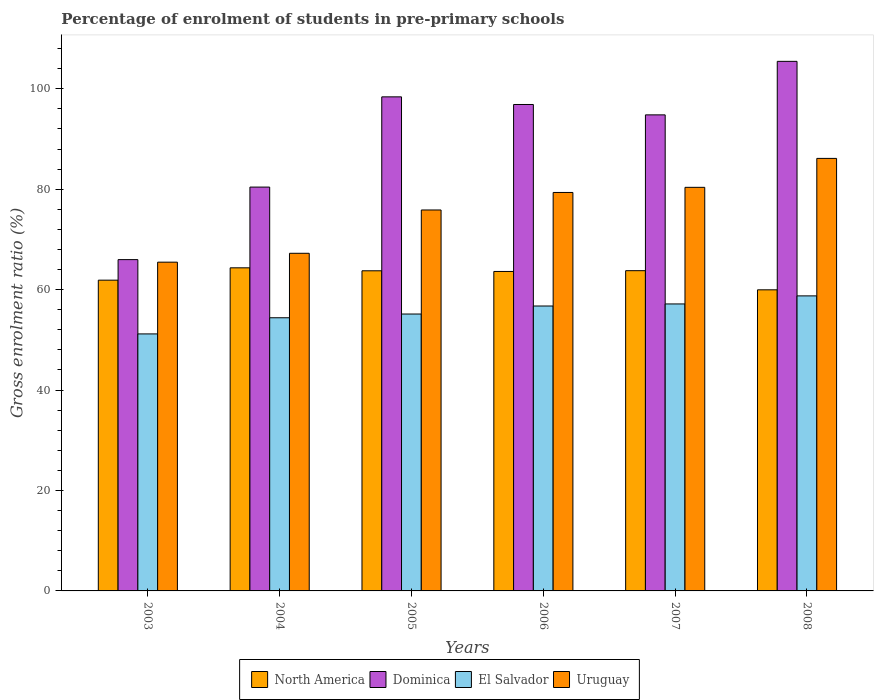How many groups of bars are there?
Offer a very short reply. 6. Are the number of bars on each tick of the X-axis equal?
Give a very brief answer. Yes. How many bars are there on the 1st tick from the left?
Your response must be concise. 4. What is the label of the 3rd group of bars from the left?
Provide a short and direct response. 2005. In how many cases, is the number of bars for a given year not equal to the number of legend labels?
Offer a very short reply. 0. What is the percentage of students enrolled in pre-primary schools in El Salvador in 2006?
Offer a terse response. 56.74. Across all years, what is the maximum percentage of students enrolled in pre-primary schools in El Salvador?
Your answer should be compact. 58.76. Across all years, what is the minimum percentage of students enrolled in pre-primary schools in Dominica?
Ensure brevity in your answer.  65.98. What is the total percentage of students enrolled in pre-primary schools in Uruguay in the graph?
Provide a succinct answer. 454.46. What is the difference between the percentage of students enrolled in pre-primary schools in Uruguay in 2005 and that in 2007?
Offer a terse response. -4.51. What is the difference between the percentage of students enrolled in pre-primary schools in El Salvador in 2008 and the percentage of students enrolled in pre-primary schools in North America in 2004?
Provide a short and direct response. -5.59. What is the average percentage of students enrolled in pre-primary schools in El Salvador per year?
Ensure brevity in your answer.  55.57. In the year 2003, what is the difference between the percentage of students enrolled in pre-primary schools in Dominica and percentage of students enrolled in pre-primary schools in North America?
Offer a very short reply. 4.09. What is the ratio of the percentage of students enrolled in pre-primary schools in North America in 2006 to that in 2007?
Keep it short and to the point. 1. Is the percentage of students enrolled in pre-primary schools in El Salvador in 2004 less than that in 2007?
Your answer should be very brief. Yes. Is the difference between the percentage of students enrolled in pre-primary schools in Dominica in 2005 and 2006 greater than the difference between the percentage of students enrolled in pre-primary schools in North America in 2005 and 2006?
Keep it short and to the point. Yes. What is the difference between the highest and the second highest percentage of students enrolled in pre-primary schools in Dominica?
Keep it short and to the point. 7.07. What is the difference between the highest and the lowest percentage of students enrolled in pre-primary schools in Dominica?
Your response must be concise. 39.49. Is the sum of the percentage of students enrolled in pre-primary schools in El Salvador in 2003 and 2006 greater than the maximum percentage of students enrolled in pre-primary schools in Uruguay across all years?
Ensure brevity in your answer.  Yes. Is it the case that in every year, the sum of the percentage of students enrolled in pre-primary schools in Dominica and percentage of students enrolled in pre-primary schools in El Salvador is greater than the sum of percentage of students enrolled in pre-primary schools in Uruguay and percentage of students enrolled in pre-primary schools in North America?
Your answer should be compact. No. What does the 2nd bar from the left in 2008 represents?
Give a very brief answer. Dominica. How many bars are there?
Offer a terse response. 24. How many years are there in the graph?
Your answer should be compact. 6. Are the values on the major ticks of Y-axis written in scientific E-notation?
Ensure brevity in your answer.  No. Does the graph contain any zero values?
Give a very brief answer. No. How are the legend labels stacked?
Ensure brevity in your answer.  Horizontal. What is the title of the graph?
Provide a short and direct response. Percentage of enrolment of students in pre-primary schools. What is the label or title of the X-axis?
Your answer should be compact. Years. What is the Gross enrolment ratio (%) of North America in 2003?
Offer a terse response. 61.89. What is the Gross enrolment ratio (%) in Dominica in 2003?
Give a very brief answer. 65.98. What is the Gross enrolment ratio (%) of El Salvador in 2003?
Offer a very short reply. 51.18. What is the Gross enrolment ratio (%) of Uruguay in 2003?
Keep it short and to the point. 65.48. What is the Gross enrolment ratio (%) of North America in 2004?
Keep it short and to the point. 64.35. What is the Gross enrolment ratio (%) of Dominica in 2004?
Your answer should be compact. 80.43. What is the Gross enrolment ratio (%) of El Salvador in 2004?
Your response must be concise. 54.4. What is the Gross enrolment ratio (%) of Uruguay in 2004?
Make the answer very short. 67.24. What is the Gross enrolment ratio (%) in North America in 2005?
Offer a very short reply. 63.76. What is the Gross enrolment ratio (%) of Dominica in 2005?
Your answer should be compact. 98.4. What is the Gross enrolment ratio (%) in El Salvador in 2005?
Give a very brief answer. 55.15. What is the Gross enrolment ratio (%) of Uruguay in 2005?
Give a very brief answer. 75.87. What is the Gross enrolment ratio (%) of North America in 2006?
Your answer should be compact. 63.62. What is the Gross enrolment ratio (%) of Dominica in 2006?
Your answer should be very brief. 96.88. What is the Gross enrolment ratio (%) in El Salvador in 2006?
Give a very brief answer. 56.74. What is the Gross enrolment ratio (%) in Uruguay in 2006?
Your answer should be very brief. 79.36. What is the Gross enrolment ratio (%) in North America in 2007?
Provide a short and direct response. 63.78. What is the Gross enrolment ratio (%) of Dominica in 2007?
Give a very brief answer. 94.81. What is the Gross enrolment ratio (%) of El Salvador in 2007?
Your answer should be very brief. 57.15. What is the Gross enrolment ratio (%) in Uruguay in 2007?
Keep it short and to the point. 80.38. What is the Gross enrolment ratio (%) in North America in 2008?
Make the answer very short. 59.97. What is the Gross enrolment ratio (%) of Dominica in 2008?
Provide a succinct answer. 105.47. What is the Gross enrolment ratio (%) of El Salvador in 2008?
Your answer should be compact. 58.76. What is the Gross enrolment ratio (%) in Uruguay in 2008?
Make the answer very short. 86.14. Across all years, what is the maximum Gross enrolment ratio (%) in North America?
Offer a terse response. 64.35. Across all years, what is the maximum Gross enrolment ratio (%) in Dominica?
Keep it short and to the point. 105.47. Across all years, what is the maximum Gross enrolment ratio (%) of El Salvador?
Keep it short and to the point. 58.76. Across all years, what is the maximum Gross enrolment ratio (%) in Uruguay?
Provide a succinct answer. 86.14. Across all years, what is the minimum Gross enrolment ratio (%) of North America?
Provide a succinct answer. 59.97. Across all years, what is the minimum Gross enrolment ratio (%) in Dominica?
Provide a succinct answer. 65.98. Across all years, what is the minimum Gross enrolment ratio (%) of El Salvador?
Make the answer very short. 51.18. Across all years, what is the minimum Gross enrolment ratio (%) of Uruguay?
Provide a short and direct response. 65.48. What is the total Gross enrolment ratio (%) in North America in the graph?
Your answer should be very brief. 377.37. What is the total Gross enrolment ratio (%) of Dominica in the graph?
Your response must be concise. 541.96. What is the total Gross enrolment ratio (%) of El Salvador in the graph?
Keep it short and to the point. 333.39. What is the total Gross enrolment ratio (%) of Uruguay in the graph?
Offer a terse response. 454.46. What is the difference between the Gross enrolment ratio (%) of North America in 2003 and that in 2004?
Your response must be concise. -2.46. What is the difference between the Gross enrolment ratio (%) of Dominica in 2003 and that in 2004?
Your answer should be compact. -14.44. What is the difference between the Gross enrolment ratio (%) of El Salvador in 2003 and that in 2004?
Give a very brief answer. -3.22. What is the difference between the Gross enrolment ratio (%) in Uruguay in 2003 and that in 2004?
Your response must be concise. -1.77. What is the difference between the Gross enrolment ratio (%) in North America in 2003 and that in 2005?
Offer a terse response. -1.87. What is the difference between the Gross enrolment ratio (%) of Dominica in 2003 and that in 2005?
Provide a short and direct response. -32.41. What is the difference between the Gross enrolment ratio (%) of El Salvador in 2003 and that in 2005?
Your answer should be compact. -3.96. What is the difference between the Gross enrolment ratio (%) in Uruguay in 2003 and that in 2005?
Ensure brevity in your answer.  -10.39. What is the difference between the Gross enrolment ratio (%) of North America in 2003 and that in 2006?
Ensure brevity in your answer.  -1.73. What is the difference between the Gross enrolment ratio (%) of Dominica in 2003 and that in 2006?
Provide a short and direct response. -30.89. What is the difference between the Gross enrolment ratio (%) in El Salvador in 2003 and that in 2006?
Offer a terse response. -5.56. What is the difference between the Gross enrolment ratio (%) in Uruguay in 2003 and that in 2006?
Give a very brief answer. -13.88. What is the difference between the Gross enrolment ratio (%) of North America in 2003 and that in 2007?
Give a very brief answer. -1.89. What is the difference between the Gross enrolment ratio (%) of Dominica in 2003 and that in 2007?
Your response must be concise. -28.83. What is the difference between the Gross enrolment ratio (%) of El Salvador in 2003 and that in 2007?
Your response must be concise. -5.97. What is the difference between the Gross enrolment ratio (%) in Uruguay in 2003 and that in 2007?
Offer a very short reply. -14.9. What is the difference between the Gross enrolment ratio (%) of North America in 2003 and that in 2008?
Provide a short and direct response. 1.92. What is the difference between the Gross enrolment ratio (%) of Dominica in 2003 and that in 2008?
Provide a succinct answer. -39.49. What is the difference between the Gross enrolment ratio (%) of El Salvador in 2003 and that in 2008?
Your answer should be compact. -7.58. What is the difference between the Gross enrolment ratio (%) in Uruguay in 2003 and that in 2008?
Offer a terse response. -20.66. What is the difference between the Gross enrolment ratio (%) in North America in 2004 and that in 2005?
Provide a succinct answer. 0.59. What is the difference between the Gross enrolment ratio (%) of Dominica in 2004 and that in 2005?
Keep it short and to the point. -17.97. What is the difference between the Gross enrolment ratio (%) in El Salvador in 2004 and that in 2005?
Your answer should be compact. -0.74. What is the difference between the Gross enrolment ratio (%) of Uruguay in 2004 and that in 2005?
Provide a short and direct response. -8.63. What is the difference between the Gross enrolment ratio (%) in North America in 2004 and that in 2006?
Give a very brief answer. 0.73. What is the difference between the Gross enrolment ratio (%) in Dominica in 2004 and that in 2006?
Keep it short and to the point. -16.45. What is the difference between the Gross enrolment ratio (%) of El Salvador in 2004 and that in 2006?
Provide a short and direct response. -2.34. What is the difference between the Gross enrolment ratio (%) in Uruguay in 2004 and that in 2006?
Make the answer very short. -12.11. What is the difference between the Gross enrolment ratio (%) of North America in 2004 and that in 2007?
Your response must be concise. 0.57. What is the difference between the Gross enrolment ratio (%) of Dominica in 2004 and that in 2007?
Your response must be concise. -14.38. What is the difference between the Gross enrolment ratio (%) of El Salvador in 2004 and that in 2007?
Keep it short and to the point. -2.75. What is the difference between the Gross enrolment ratio (%) of Uruguay in 2004 and that in 2007?
Your response must be concise. -13.14. What is the difference between the Gross enrolment ratio (%) of North America in 2004 and that in 2008?
Offer a very short reply. 4.38. What is the difference between the Gross enrolment ratio (%) in Dominica in 2004 and that in 2008?
Give a very brief answer. -25.04. What is the difference between the Gross enrolment ratio (%) in El Salvador in 2004 and that in 2008?
Offer a very short reply. -4.36. What is the difference between the Gross enrolment ratio (%) of Uruguay in 2004 and that in 2008?
Provide a short and direct response. -18.9. What is the difference between the Gross enrolment ratio (%) in North America in 2005 and that in 2006?
Offer a very short reply. 0.14. What is the difference between the Gross enrolment ratio (%) in Dominica in 2005 and that in 2006?
Ensure brevity in your answer.  1.52. What is the difference between the Gross enrolment ratio (%) in El Salvador in 2005 and that in 2006?
Your answer should be very brief. -1.6. What is the difference between the Gross enrolment ratio (%) in Uruguay in 2005 and that in 2006?
Offer a very short reply. -3.49. What is the difference between the Gross enrolment ratio (%) of North America in 2005 and that in 2007?
Ensure brevity in your answer.  -0.02. What is the difference between the Gross enrolment ratio (%) of Dominica in 2005 and that in 2007?
Give a very brief answer. 3.59. What is the difference between the Gross enrolment ratio (%) of El Salvador in 2005 and that in 2007?
Your response must be concise. -2.01. What is the difference between the Gross enrolment ratio (%) of Uruguay in 2005 and that in 2007?
Provide a succinct answer. -4.51. What is the difference between the Gross enrolment ratio (%) in North America in 2005 and that in 2008?
Your answer should be compact. 3.79. What is the difference between the Gross enrolment ratio (%) of Dominica in 2005 and that in 2008?
Make the answer very short. -7.07. What is the difference between the Gross enrolment ratio (%) in El Salvador in 2005 and that in 2008?
Give a very brief answer. -3.61. What is the difference between the Gross enrolment ratio (%) of Uruguay in 2005 and that in 2008?
Your response must be concise. -10.27. What is the difference between the Gross enrolment ratio (%) in North America in 2006 and that in 2007?
Make the answer very short. -0.16. What is the difference between the Gross enrolment ratio (%) of Dominica in 2006 and that in 2007?
Offer a very short reply. 2.07. What is the difference between the Gross enrolment ratio (%) in El Salvador in 2006 and that in 2007?
Keep it short and to the point. -0.41. What is the difference between the Gross enrolment ratio (%) in Uruguay in 2006 and that in 2007?
Your answer should be very brief. -1.02. What is the difference between the Gross enrolment ratio (%) in North America in 2006 and that in 2008?
Keep it short and to the point. 3.65. What is the difference between the Gross enrolment ratio (%) in Dominica in 2006 and that in 2008?
Offer a terse response. -8.59. What is the difference between the Gross enrolment ratio (%) of El Salvador in 2006 and that in 2008?
Your answer should be very brief. -2.02. What is the difference between the Gross enrolment ratio (%) of Uruguay in 2006 and that in 2008?
Your answer should be compact. -6.78. What is the difference between the Gross enrolment ratio (%) of North America in 2007 and that in 2008?
Ensure brevity in your answer.  3.81. What is the difference between the Gross enrolment ratio (%) in Dominica in 2007 and that in 2008?
Keep it short and to the point. -10.66. What is the difference between the Gross enrolment ratio (%) in El Salvador in 2007 and that in 2008?
Offer a very short reply. -1.61. What is the difference between the Gross enrolment ratio (%) of Uruguay in 2007 and that in 2008?
Offer a terse response. -5.76. What is the difference between the Gross enrolment ratio (%) in North America in 2003 and the Gross enrolment ratio (%) in Dominica in 2004?
Your response must be concise. -18.54. What is the difference between the Gross enrolment ratio (%) in North America in 2003 and the Gross enrolment ratio (%) in El Salvador in 2004?
Make the answer very short. 7.48. What is the difference between the Gross enrolment ratio (%) in North America in 2003 and the Gross enrolment ratio (%) in Uruguay in 2004?
Your answer should be compact. -5.35. What is the difference between the Gross enrolment ratio (%) of Dominica in 2003 and the Gross enrolment ratio (%) of El Salvador in 2004?
Give a very brief answer. 11.58. What is the difference between the Gross enrolment ratio (%) of Dominica in 2003 and the Gross enrolment ratio (%) of Uruguay in 2004?
Offer a very short reply. -1.26. What is the difference between the Gross enrolment ratio (%) of El Salvador in 2003 and the Gross enrolment ratio (%) of Uruguay in 2004?
Make the answer very short. -16.06. What is the difference between the Gross enrolment ratio (%) of North America in 2003 and the Gross enrolment ratio (%) of Dominica in 2005?
Offer a terse response. -36.51. What is the difference between the Gross enrolment ratio (%) of North America in 2003 and the Gross enrolment ratio (%) of El Salvador in 2005?
Keep it short and to the point. 6.74. What is the difference between the Gross enrolment ratio (%) of North America in 2003 and the Gross enrolment ratio (%) of Uruguay in 2005?
Offer a very short reply. -13.98. What is the difference between the Gross enrolment ratio (%) of Dominica in 2003 and the Gross enrolment ratio (%) of El Salvador in 2005?
Provide a succinct answer. 10.84. What is the difference between the Gross enrolment ratio (%) in Dominica in 2003 and the Gross enrolment ratio (%) in Uruguay in 2005?
Give a very brief answer. -9.89. What is the difference between the Gross enrolment ratio (%) of El Salvador in 2003 and the Gross enrolment ratio (%) of Uruguay in 2005?
Keep it short and to the point. -24.68. What is the difference between the Gross enrolment ratio (%) of North America in 2003 and the Gross enrolment ratio (%) of Dominica in 2006?
Make the answer very short. -34.99. What is the difference between the Gross enrolment ratio (%) of North America in 2003 and the Gross enrolment ratio (%) of El Salvador in 2006?
Give a very brief answer. 5.15. What is the difference between the Gross enrolment ratio (%) of North America in 2003 and the Gross enrolment ratio (%) of Uruguay in 2006?
Ensure brevity in your answer.  -17.47. What is the difference between the Gross enrolment ratio (%) in Dominica in 2003 and the Gross enrolment ratio (%) in El Salvador in 2006?
Offer a terse response. 9.24. What is the difference between the Gross enrolment ratio (%) in Dominica in 2003 and the Gross enrolment ratio (%) in Uruguay in 2006?
Provide a short and direct response. -13.37. What is the difference between the Gross enrolment ratio (%) of El Salvador in 2003 and the Gross enrolment ratio (%) of Uruguay in 2006?
Provide a short and direct response. -28.17. What is the difference between the Gross enrolment ratio (%) of North America in 2003 and the Gross enrolment ratio (%) of Dominica in 2007?
Your answer should be compact. -32.92. What is the difference between the Gross enrolment ratio (%) in North America in 2003 and the Gross enrolment ratio (%) in El Salvador in 2007?
Give a very brief answer. 4.74. What is the difference between the Gross enrolment ratio (%) in North America in 2003 and the Gross enrolment ratio (%) in Uruguay in 2007?
Offer a very short reply. -18.49. What is the difference between the Gross enrolment ratio (%) in Dominica in 2003 and the Gross enrolment ratio (%) in El Salvador in 2007?
Your response must be concise. 8.83. What is the difference between the Gross enrolment ratio (%) in Dominica in 2003 and the Gross enrolment ratio (%) in Uruguay in 2007?
Keep it short and to the point. -14.39. What is the difference between the Gross enrolment ratio (%) of El Salvador in 2003 and the Gross enrolment ratio (%) of Uruguay in 2007?
Make the answer very short. -29.19. What is the difference between the Gross enrolment ratio (%) in North America in 2003 and the Gross enrolment ratio (%) in Dominica in 2008?
Ensure brevity in your answer.  -43.58. What is the difference between the Gross enrolment ratio (%) of North America in 2003 and the Gross enrolment ratio (%) of El Salvador in 2008?
Ensure brevity in your answer.  3.13. What is the difference between the Gross enrolment ratio (%) of North America in 2003 and the Gross enrolment ratio (%) of Uruguay in 2008?
Your response must be concise. -24.25. What is the difference between the Gross enrolment ratio (%) in Dominica in 2003 and the Gross enrolment ratio (%) in El Salvador in 2008?
Offer a terse response. 7.22. What is the difference between the Gross enrolment ratio (%) in Dominica in 2003 and the Gross enrolment ratio (%) in Uruguay in 2008?
Keep it short and to the point. -20.16. What is the difference between the Gross enrolment ratio (%) of El Salvador in 2003 and the Gross enrolment ratio (%) of Uruguay in 2008?
Provide a succinct answer. -34.96. What is the difference between the Gross enrolment ratio (%) of North America in 2004 and the Gross enrolment ratio (%) of Dominica in 2005?
Offer a very short reply. -34.05. What is the difference between the Gross enrolment ratio (%) in North America in 2004 and the Gross enrolment ratio (%) in El Salvador in 2005?
Offer a very short reply. 9.2. What is the difference between the Gross enrolment ratio (%) in North America in 2004 and the Gross enrolment ratio (%) in Uruguay in 2005?
Offer a very short reply. -11.52. What is the difference between the Gross enrolment ratio (%) in Dominica in 2004 and the Gross enrolment ratio (%) in El Salvador in 2005?
Your response must be concise. 25.28. What is the difference between the Gross enrolment ratio (%) in Dominica in 2004 and the Gross enrolment ratio (%) in Uruguay in 2005?
Offer a very short reply. 4.56. What is the difference between the Gross enrolment ratio (%) in El Salvador in 2004 and the Gross enrolment ratio (%) in Uruguay in 2005?
Keep it short and to the point. -21.46. What is the difference between the Gross enrolment ratio (%) of North America in 2004 and the Gross enrolment ratio (%) of Dominica in 2006?
Offer a terse response. -32.53. What is the difference between the Gross enrolment ratio (%) of North America in 2004 and the Gross enrolment ratio (%) of El Salvador in 2006?
Provide a succinct answer. 7.61. What is the difference between the Gross enrolment ratio (%) in North America in 2004 and the Gross enrolment ratio (%) in Uruguay in 2006?
Make the answer very short. -15.01. What is the difference between the Gross enrolment ratio (%) in Dominica in 2004 and the Gross enrolment ratio (%) in El Salvador in 2006?
Make the answer very short. 23.68. What is the difference between the Gross enrolment ratio (%) of Dominica in 2004 and the Gross enrolment ratio (%) of Uruguay in 2006?
Ensure brevity in your answer.  1.07. What is the difference between the Gross enrolment ratio (%) in El Salvador in 2004 and the Gross enrolment ratio (%) in Uruguay in 2006?
Offer a very short reply. -24.95. What is the difference between the Gross enrolment ratio (%) of North America in 2004 and the Gross enrolment ratio (%) of Dominica in 2007?
Provide a succinct answer. -30.46. What is the difference between the Gross enrolment ratio (%) in North America in 2004 and the Gross enrolment ratio (%) in El Salvador in 2007?
Give a very brief answer. 7.2. What is the difference between the Gross enrolment ratio (%) of North America in 2004 and the Gross enrolment ratio (%) of Uruguay in 2007?
Make the answer very short. -16.03. What is the difference between the Gross enrolment ratio (%) in Dominica in 2004 and the Gross enrolment ratio (%) in El Salvador in 2007?
Give a very brief answer. 23.27. What is the difference between the Gross enrolment ratio (%) in Dominica in 2004 and the Gross enrolment ratio (%) in Uruguay in 2007?
Give a very brief answer. 0.05. What is the difference between the Gross enrolment ratio (%) in El Salvador in 2004 and the Gross enrolment ratio (%) in Uruguay in 2007?
Your response must be concise. -25.97. What is the difference between the Gross enrolment ratio (%) in North America in 2004 and the Gross enrolment ratio (%) in Dominica in 2008?
Provide a short and direct response. -41.12. What is the difference between the Gross enrolment ratio (%) of North America in 2004 and the Gross enrolment ratio (%) of El Salvador in 2008?
Provide a short and direct response. 5.59. What is the difference between the Gross enrolment ratio (%) of North America in 2004 and the Gross enrolment ratio (%) of Uruguay in 2008?
Your response must be concise. -21.79. What is the difference between the Gross enrolment ratio (%) of Dominica in 2004 and the Gross enrolment ratio (%) of El Salvador in 2008?
Your answer should be compact. 21.67. What is the difference between the Gross enrolment ratio (%) in Dominica in 2004 and the Gross enrolment ratio (%) in Uruguay in 2008?
Your response must be concise. -5.71. What is the difference between the Gross enrolment ratio (%) of El Salvador in 2004 and the Gross enrolment ratio (%) of Uruguay in 2008?
Ensure brevity in your answer.  -31.74. What is the difference between the Gross enrolment ratio (%) in North America in 2005 and the Gross enrolment ratio (%) in Dominica in 2006?
Provide a short and direct response. -33.12. What is the difference between the Gross enrolment ratio (%) of North America in 2005 and the Gross enrolment ratio (%) of El Salvador in 2006?
Offer a terse response. 7.01. What is the difference between the Gross enrolment ratio (%) of North America in 2005 and the Gross enrolment ratio (%) of Uruguay in 2006?
Provide a succinct answer. -15.6. What is the difference between the Gross enrolment ratio (%) in Dominica in 2005 and the Gross enrolment ratio (%) in El Salvador in 2006?
Your answer should be compact. 41.65. What is the difference between the Gross enrolment ratio (%) of Dominica in 2005 and the Gross enrolment ratio (%) of Uruguay in 2006?
Offer a terse response. 19.04. What is the difference between the Gross enrolment ratio (%) of El Salvador in 2005 and the Gross enrolment ratio (%) of Uruguay in 2006?
Give a very brief answer. -24.21. What is the difference between the Gross enrolment ratio (%) in North America in 2005 and the Gross enrolment ratio (%) in Dominica in 2007?
Ensure brevity in your answer.  -31.05. What is the difference between the Gross enrolment ratio (%) of North America in 2005 and the Gross enrolment ratio (%) of El Salvador in 2007?
Keep it short and to the point. 6.6. What is the difference between the Gross enrolment ratio (%) in North America in 2005 and the Gross enrolment ratio (%) in Uruguay in 2007?
Make the answer very short. -16.62. What is the difference between the Gross enrolment ratio (%) in Dominica in 2005 and the Gross enrolment ratio (%) in El Salvador in 2007?
Your response must be concise. 41.24. What is the difference between the Gross enrolment ratio (%) in Dominica in 2005 and the Gross enrolment ratio (%) in Uruguay in 2007?
Offer a very short reply. 18.02. What is the difference between the Gross enrolment ratio (%) in El Salvador in 2005 and the Gross enrolment ratio (%) in Uruguay in 2007?
Provide a short and direct response. -25.23. What is the difference between the Gross enrolment ratio (%) in North America in 2005 and the Gross enrolment ratio (%) in Dominica in 2008?
Ensure brevity in your answer.  -41.71. What is the difference between the Gross enrolment ratio (%) of North America in 2005 and the Gross enrolment ratio (%) of El Salvador in 2008?
Offer a very short reply. 5. What is the difference between the Gross enrolment ratio (%) in North America in 2005 and the Gross enrolment ratio (%) in Uruguay in 2008?
Offer a very short reply. -22.38. What is the difference between the Gross enrolment ratio (%) in Dominica in 2005 and the Gross enrolment ratio (%) in El Salvador in 2008?
Your answer should be very brief. 39.64. What is the difference between the Gross enrolment ratio (%) of Dominica in 2005 and the Gross enrolment ratio (%) of Uruguay in 2008?
Give a very brief answer. 12.26. What is the difference between the Gross enrolment ratio (%) in El Salvador in 2005 and the Gross enrolment ratio (%) in Uruguay in 2008?
Provide a succinct answer. -30.99. What is the difference between the Gross enrolment ratio (%) in North America in 2006 and the Gross enrolment ratio (%) in Dominica in 2007?
Your response must be concise. -31.19. What is the difference between the Gross enrolment ratio (%) in North America in 2006 and the Gross enrolment ratio (%) in El Salvador in 2007?
Ensure brevity in your answer.  6.47. What is the difference between the Gross enrolment ratio (%) in North America in 2006 and the Gross enrolment ratio (%) in Uruguay in 2007?
Keep it short and to the point. -16.75. What is the difference between the Gross enrolment ratio (%) in Dominica in 2006 and the Gross enrolment ratio (%) in El Salvador in 2007?
Your response must be concise. 39.72. What is the difference between the Gross enrolment ratio (%) of Dominica in 2006 and the Gross enrolment ratio (%) of Uruguay in 2007?
Your answer should be very brief. 16.5. What is the difference between the Gross enrolment ratio (%) in El Salvador in 2006 and the Gross enrolment ratio (%) in Uruguay in 2007?
Your response must be concise. -23.63. What is the difference between the Gross enrolment ratio (%) in North America in 2006 and the Gross enrolment ratio (%) in Dominica in 2008?
Your answer should be compact. -41.85. What is the difference between the Gross enrolment ratio (%) in North America in 2006 and the Gross enrolment ratio (%) in El Salvador in 2008?
Provide a succinct answer. 4.86. What is the difference between the Gross enrolment ratio (%) of North America in 2006 and the Gross enrolment ratio (%) of Uruguay in 2008?
Make the answer very short. -22.52. What is the difference between the Gross enrolment ratio (%) of Dominica in 2006 and the Gross enrolment ratio (%) of El Salvador in 2008?
Keep it short and to the point. 38.12. What is the difference between the Gross enrolment ratio (%) in Dominica in 2006 and the Gross enrolment ratio (%) in Uruguay in 2008?
Provide a succinct answer. 10.74. What is the difference between the Gross enrolment ratio (%) in El Salvador in 2006 and the Gross enrolment ratio (%) in Uruguay in 2008?
Offer a very short reply. -29.4. What is the difference between the Gross enrolment ratio (%) of North America in 2007 and the Gross enrolment ratio (%) of Dominica in 2008?
Your answer should be very brief. -41.69. What is the difference between the Gross enrolment ratio (%) in North America in 2007 and the Gross enrolment ratio (%) in El Salvador in 2008?
Your answer should be very brief. 5.02. What is the difference between the Gross enrolment ratio (%) in North America in 2007 and the Gross enrolment ratio (%) in Uruguay in 2008?
Your answer should be compact. -22.36. What is the difference between the Gross enrolment ratio (%) of Dominica in 2007 and the Gross enrolment ratio (%) of El Salvador in 2008?
Offer a terse response. 36.05. What is the difference between the Gross enrolment ratio (%) in Dominica in 2007 and the Gross enrolment ratio (%) in Uruguay in 2008?
Your answer should be compact. 8.67. What is the difference between the Gross enrolment ratio (%) of El Salvador in 2007 and the Gross enrolment ratio (%) of Uruguay in 2008?
Offer a terse response. -28.99. What is the average Gross enrolment ratio (%) of North America per year?
Provide a short and direct response. 62.89. What is the average Gross enrolment ratio (%) of Dominica per year?
Offer a very short reply. 90.33. What is the average Gross enrolment ratio (%) in El Salvador per year?
Offer a terse response. 55.57. What is the average Gross enrolment ratio (%) in Uruguay per year?
Provide a succinct answer. 75.74. In the year 2003, what is the difference between the Gross enrolment ratio (%) in North America and Gross enrolment ratio (%) in Dominica?
Your answer should be compact. -4.09. In the year 2003, what is the difference between the Gross enrolment ratio (%) in North America and Gross enrolment ratio (%) in El Salvador?
Ensure brevity in your answer.  10.7. In the year 2003, what is the difference between the Gross enrolment ratio (%) of North America and Gross enrolment ratio (%) of Uruguay?
Provide a succinct answer. -3.59. In the year 2003, what is the difference between the Gross enrolment ratio (%) in Dominica and Gross enrolment ratio (%) in El Salvador?
Your answer should be very brief. 14.8. In the year 2003, what is the difference between the Gross enrolment ratio (%) of Dominica and Gross enrolment ratio (%) of Uruguay?
Give a very brief answer. 0.51. In the year 2003, what is the difference between the Gross enrolment ratio (%) in El Salvador and Gross enrolment ratio (%) in Uruguay?
Provide a short and direct response. -14.29. In the year 2004, what is the difference between the Gross enrolment ratio (%) of North America and Gross enrolment ratio (%) of Dominica?
Your answer should be compact. -16.08. In the year 2004, what is the difference between the Gross enrolment ratio (%) of North America and Gross enrolment ratio (%) of El Salvador?
Give a very brief answer. 9.94. In the year 2004, what is the difference between the Gross enrolment ratio (%) in North America and Gross enrolment ratio (%) in Uruguay?
Give a very brief answer. -2.89. In the year 2004, what is the difference between the Gross enrolment ratio (%) in Dominica and Gross enrolment ratio (%) in El Salvador?
Your response must be concise. 26.02. In the year 2004, what is the difference between the Gross enrolment ratio (%) of Dominica and Gross enrolment ratio (%) of Uruguay?
Offer a terse response. 13.18. In the year 2004, what is the difference between the Gross enrolment ratio (%) in El Salvador and Gross enrolment ratio (%) in Uruguay?
Offer a very short reply. -12.84. In the year 2005, what is the difference between the Gross enrolment ratio (%) of North America and Gross enrolment ratio (%) of Dominica?
Offer a very short reply. -34.64. In the year 2005, what is the difference between the Gross enrolment ratio (%) in North America and Gross enrolment ratio (%) in El Salvador?
Offer a terse response. 8.61. In the year 2005, what is the difference between the Gross enrolment ratio (%) of North America and Gross enrolment ratio (%) of Uruguay?
Offer a very short reply. -12.11. In the year 2005, what is the difference between the Gross enrolment ratio (%) in Dominica and Gross enrolment ratio (%) in El Salvador?
Keep it short and to the point. 43.25. In the year 2005, what is the difference between the Gross enrolment ratio (%) of Dominica and Gross enrolment ratio (%) of Uruguay?
Ensure brevity in your answer.  22.53. In the year 2005, what is the difference between the Gross enrolment ratio (%) of El Salvador and Gross enrolment ratio (%) of Uruguay?
Provide a succinct answer. -20.72. In the year 2006, what is the difference between the Gross enrolment ratio (%) in North America and Gross enrolment ratio (%) in Dominica?
Your response must be concise. -33.25. In the year 2006, what is the difference between the Gross enrolment ratio (%) in North America and Gross enrolment ratio (%) in El Salvador?
Your answer should be compact. 6.88. In the year 2006, what is the difference between the Gross enrolment ratio (%) of North America and Gross enrolment ratio (%) of Uruguay?
Your answer should be very brief. -15.73. In the year 2006, what is the difference between the Gross enrolment ratio (%) in Dominica and Gross enrolment ratio (%) in El Salvador?
Provide a short and direct response. 40.13. In the year 2006, what is the difference between the Gross enrolment ratio (%) in Dominica and Gross enrolment ratio (%) in Uruguay?
Keep it short and to the point. 17.52. In the year 2006, what is the difference between the Gross enrolment ratio (%) of El Salvador and Gross enrolment ratio (%) of Uruguay?
Keep it short and to the point. -22.61. In the year 2007, what is the difference between the Gross enrolment ratio (%) in North America and Gross enrolment ratio (%) in Dominica?
Give a very brief answer. -31.03. In the year 2007, what is the difference between the Gross enrolment ratio (%) in North America and Gross enrolment ratio (%) in El Salvador?
Your answer should be very brief. 6.62. In the year 2007, what is the difference between the Gross enrolment ratio (%) in North America and Gross enrolment ratio (%) in Uruguay?
Make the answer very short. -16.6. In the year 2007, what is the difference between the Gross enrolment ratio (%) of Dominica and Gross enrolment ratio (%) of El Salvador?
Offer a very short reply. 37.66. In the year 2007, what is the difference between the Gross enrolment ratio (%) of Dominica and Gross enrolment ratio (%) of Uruguay?
Your response must be concise. 14.43. In the year 2007, what is the difference between the Gross enrolment ratio (%) of El Salvador and Gross enrolment ratio (%) of Uruguay?
Offer a very short reply. -23.22. In the year 2008, what is the difference between the Gross enrolment ratio (%) of North America and Gross enrolment ratio (%) of Dominica?
Your response must be concise. -45.5. In the year 2008, what is the difference between the Gross enrolment ratio (%) of North America and Gross enrolment ratio (%) of El Salvador?
Offer a very short reply. 1.21. In the year 2008, what is the difference between the Gross enrolment ratio (%) in North America and Gross enrolment ratio (%) in Uruguay?
Provide a short and direct response. -26.17. In the year 2008, what is the difference between the Gross enrolment ratio (%) of Dominica and Gross enrolment ratio (%) of El Salvador?
Your answer should be very brief. 46.71. In the year 2008, what is the difference between the Gross enrolment ratio (%) in Dominica and Gross enrolment ratio (%) in Uruguay?
Provide a short and direct response. 19.33. In the year 2008, what is the difference between the Gross enrolment ratio (%) of El Salvador and Gross enrolment ratio (%) of Uruguay?
Offer a very short reply. -27.38. What is the ratio of the Gross enrolment ratio (%) in North America in 2003 to that in 2004?
Ensure brevity in your answer.  0.96. What is the ratio of the Gross enrolment ratio (%) in Dominica in 2003 to that in 2004?
Keep it short and to the point. 0.82. What is the ratio of the Gross enrolment ratio (%) of El Salvador in 2003 to that in 2004?
Offer a terse response. 0.94. What is the ratio of the Gross enrolment ratio (%) in Uruguay in 2003 to that in 2004?
Give a very brief answer. 0.97. What is the ratio of the Gross enrolment ratio (%) in North America in 2003 to that in 2005?
Offer a terse response. 0.97. What is the ratio of the Gross enrolment ratio (%) in Dominica in 2003 to that in 2005?
Your response must be concise. 0.67. What is the ratio of the Gross enrolment ratio (%) in El Salvador in 2003 to that in 2005?
Provide a short and direct response. 0.93. What is the ratio of the Gross enrolment ratio (%) of Uruguay in 2003 to that in 2005?
Make the answer very short. 0.86. What is the ratio of the Gross enrolment ratio (%) of North America in 2003 to that in 2006?
Keep it short and to the point. 0.97. What is the ratio of the Gross enrolment ratio (%) of Dominica in 2003 to that in 2006?
Offer a terse response. 0.68. What is the ratio of the Gross enrolment ratio (%) in El Salvador in 2003 to that in 2006?
Your answer should be compact. 0.9. What is the ratio of the Gross enrolment ratio (%) of Uruguay in 2003 to that in 2006?
Your response must be concise. 0.83. What is the ratio of the Gross enrolment ratio (%) in North America in 2003 to that in 2007?
Offer a terse response. 0.97. What is the ratio of the Gross enrolment ratio (%) of Dominica in 2003 to that in 2007?
Offer a terse response. 0.7. What is the ratio of the Gross enrolment ratio (%) in El Salvador in 2003 to that in 2007?
Give a very brief answer. 0.9. What is the ratio of the Gross enrolment ratio (%) of Uruguay in 2003 to that in 2007?
Make the answer very short. 0.81. What is the ratio of the Gross enrolment ratio (%) of North America in 2003 to that in 2008?
Your answer should be very brief. 1.03. What is the ratio of the Gross enrolment ratio (%) of Dominica in 2003 to that in 2008?
Ensure brevity in your answer.  0.63. What is the ratio of the Gross enrolment ratio (%) in El Salvador in 2003 to that in 2008?
Give a very brief answer. 0.87. What is the ratio of the Gross enrolment ratio (%) of Uruguay in 2003 to that in 2008?
Keep it short and to the point. 0.76. What is the ratio of the Gross enrolment ratio (%) of North America in 2004 to that in 2005?
Keep it short and to the point. 1.01. What is the ratio of the Gross enrolment ratio (%) of Dominica in 2004 to that in 2005?
Provide a short and direct response. 0.82. What is the ratio of the Gross enrolment ratio (%) in El Salvador in 2004 to that in 2005?
Your response must be concise. 0.99. What is the ratio of the Gross enrolment ratio (%) of Uruguay in 2004 to that in 2005?
Ensure brevity in your answer.  0.89. What is the ratio of the Gross enrolment ratio (%) in North America in 2004 to that in 2006?
Keep it short and to the point. 1.01. What is the ratio of the Gross enrolment ratio (%) of Dominica in 2004 to that in 2006?
Keep it short and to the point. 0.83. What is the ratio of the Gross enrolment ratio (%) in El Salvador in 2004 to that in 2006?
Offer a very short reply. 0.96. What is the ratio of the Gross enrolment ratio (%) in Uruguay in 2004 to that in 2006?
Provide a short and direct response. 0.85. What is the ratio of the Gross enrolment ratio (%) in North America in 2004 to that in 2007?
Your response must be concise. 1.01. What is the ratio of the Gross enrolment ratio (%) of Dominica in 2004 to that in 2007?
Offer a very short reply. 0.85. What is the ratio of the Gross enrolment ratio (%) in El Salvador in 2004 to that in 2007?
Make the answer very short. 0.95. What is the ratio of the Gross enrolment ratio (%) of Uruguay in 2004 to that in 2007?
Ensure brevity in your answer.  0.84. What is the ratio of the Gross enrolment ratio (%) in North America in 2004 to that in 2008?
Provide a succinct answer. 1.07. What is the ratio of the Gross enrolment ratio (%) in Dominica in 2004 to that in 2008?
Ensure brevity in your answer.  0.76. What is the ratio of the Gross enrolment ratio (%) of El Salvador in 2004 to that in 2008?
Provide a short and direct response. 0.93. What is the ratio of the Gross enrolment ratio (%) in Uruguay in 2004 to that in 2008?
Your answer should be compact. 0.78. What is the ratio of the Gross enrolment ratio (%) in Dominica in 2005 to that in 2006?
Your answer should be compact. 1.02. What is the ratio of the Gross enrolment ratio (%) of El Salvador in 2005 to that in 2006?
Ensure brevity in your answer.  0.97. What is the ratio of the Gross enrolment ratio (%) in Uruguay in 2005 to that in 2006?
Your answer should be compact. 0.96. What is the ratio of the Gross enrolment ratio (%) in North America in 2005 to that in 2007?
Your answer should be very brief. 1. What is the ratio of the Gross enrolment ratio (%) in Dominica in 2005 to that in 2007?
Offer a terse response. 1.04. What is the ratio of the Gross enrolment ratio (%) of El Salvador in 2005 to that in 2007?
Offer a terse response. 0.96. What is the ratio of the Gross enrolment ratio (%) of Uruguay in 2005 to that in 2007?
Ensure brevity in your answer.  0.94. What is the ratio of the Gross enrolment ratio (%) in North America in 2005 to that in 2008?
Offer a terse response. 1.06. What is the ratio of the Gross enrolment ratio (%) in Dominica in 2005 to that in 2008?
Offer a terse response. 0.93. What is the ratio of the Gross enrolment ratio (%) in El Salvador in 2005 to that in 2008?
Your answer should be compact. 0.94. What is the ratio of the Gross enrolment ratio (%) of Uruguay in 2005 to that in 2008?
Keep it short and to the point. 0.88. What is the ratio of the Gross enrolment ratio (%) of Dominica in 2006 to that in 2007?
Your answer should be compact. 1.02. What is the ratio of the Gross enrolment ratio (%) in Uruguay in 2006 to that in 2007?
Keep it short and to the point. 0.99. What is the ratio of the Gross enrolment ratio (%) of North America in 2006 to that in 2008?
Give a very brief answer. 1.06. What is the ratio of the Gross enrolment ratio (%) of Dominica in 2006 to that in 2008?
Your response must be concise. 0.92. What is the ratio of the Gross enrolment ratio (%) of El Salvador in 2006 to that in 2008?
Your response must be concise. 0.97. What is the ratio of the Gross enrolment ratio (%) of Uruguay in 2006 to that in 2008?
Make the answer very short. 0.92. What is the ratio of the Gross enrolment ratio (%) of North America in 2007 to that in 2008?
Provide a short and direct response. 1.06. What is the ratio of the Gross enrolment ratio (%) of Dominica in 2007 to that in 2008?
Your answer should be very brief. 0.9. What is the ratio of the Gross enrolment ratio (%) in El Salvador in 2007 to that in 2008?
Provide a succinct answer. 0.97. What is the ratio of the Gross enrolment ratio (%) in Uruguay in 2007 to that in 2008?
Your response must be concise. 0.93. What is the difference between the highest and the second highest Gross enrolment ratio (%) of North America?
Offer a very short reply. 0.57. What is the difference between the highest and the second highest Gross enrolment ratio (%) of Dominica?
Make the answer very short. 7.07. What is the difference between the highest and the second highest Gross enrolment ratio (%) of El Salvador?
Ensure brevity in your answer.  1.61. What is the difference between the highest and the second highest Gross enrolment ratio (%) of Uruguay?
Provide a short and direct response. 5.76. What is the difference between the highest and the lowest Gross enrolment ratio (%) of North America?
Keep it short and to the point. 4.38. What is the difference between the highest and the lowest Gross enrolment ratio (%) in Dominica?
Provide a succinct answer. 39.49. What is the difference between the highest and the lowest Gross enrolment ratio (%) in El Salvador?
Your answer should be compact. 7.58. What is the difference between the highest and the lowest Gross enrolment ratio (%) in Uruguay?
Your answer should be very brief. 20.66. 